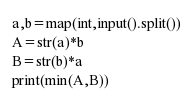<code> <loc_0><loc_0><loc_500><loc_500><_Python_>a,b=map(int,input().split())
A=str(a)*b
B=str(b)*a
print(min(A,B))
</code> 